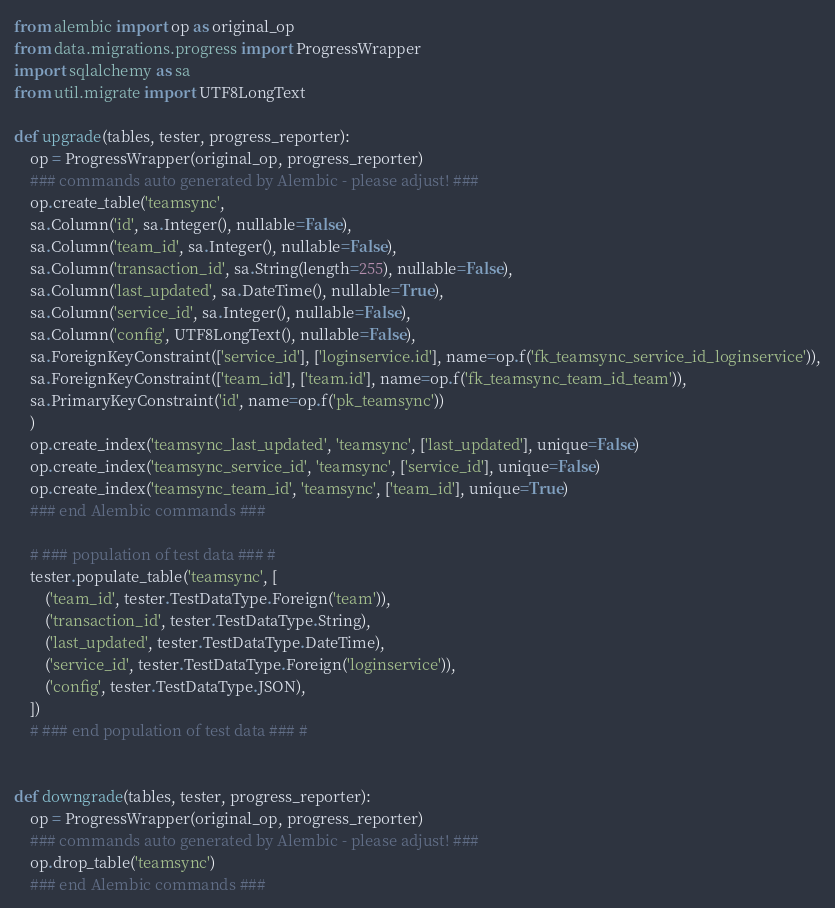<code> <loc_0><loc_0><loc_500><loc_500><_Python_>
from alembic import op as original_op
from data.migrations.progress import ProgressWrapper
import sqlalchemy as sa
from util.migrate import UTF8LongText

def upgrade(tables, tester, progress_reporter):
    op = ProgressWrapper(original_op, progress_reporter)
    ### commands auto generated by Alembic - please adjust! ###
    op.create_table('teamsync',
    sa.Column('id', sa.Integer(), nullable=False),
    sa.Column('team_id', sa.Integer(), nullable=False),
    sa.Column('transaction_id', sa.String(length=255), nullable=False),
    sa.Column('last_updated', sa.DateTime(), nullable=True),
    sa.Column('service_id', sa.Integer(), nullable=False),
    sa.Column('config', UTF8LongText(), nullable=False),
    sa.ForeignKeyConstraint(['service_id'], ['loginservice.id'], name=op.f('fk_teamsync_service_id_loginservice')),
    sa.ForeignKeyConstraint(['team_id'], ['team.id'], name=op.f('fk_teamsync_team_id_team')),
    sa.PrimaryKeyConstraint('id', name=op.f('pk_teamsync'))
    )
    op.create_index('teamsync_last_updated', 'teamsync', ['last_updated'], unique=False)
    op.create_index('teamsync_service_id', 'teamsync', ['service_id'], unique=False)
    op.create_index('teamsync_team_id', 'teamsync', ['team_id'], unique=True)
    ### end Alembic commands ###

    # ### population of test data ### #
    tester.populate_table('teamsync', [
        ('team_id', tester.TestDataType.Foreign('team')),
        ('transaction_id', tester.TestDataType.String),
        ('last_updated', tester.TestDataType.DateTime),
        ('service_id', tester.TestDataType.Foreign('loginservice')),
        ('config', tester.TestDataType.JSON),
    ])
    # ### end population of test data ### #


def downgrade(tables, tester, progress_reporter):
    op = ProgressWrapper(original_op, progress_reporter)
    ### commands auto generated by Alembic - please adjust! ###
    op.drop_table('teamsync')
    ### end Alembic commands ###
</code> 